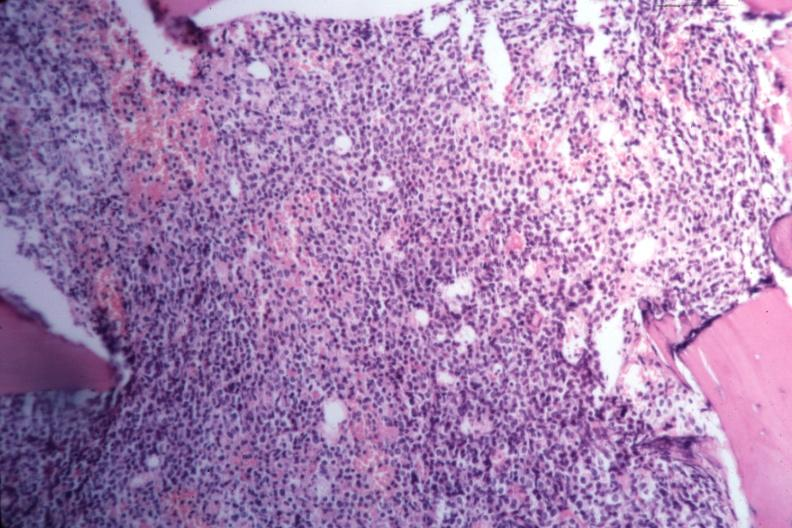what is present?
Answer the question using a single word or phrase. Hematologic 